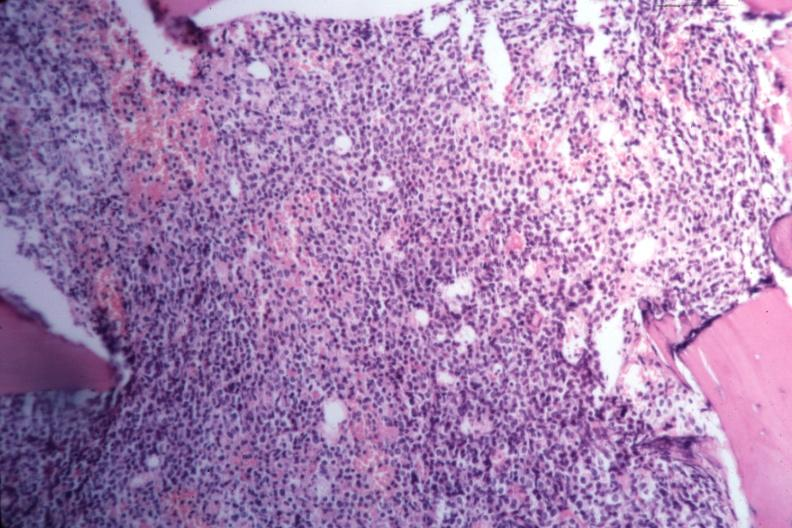what is present?
Answer the question using a single word or phrase. Hematologic 